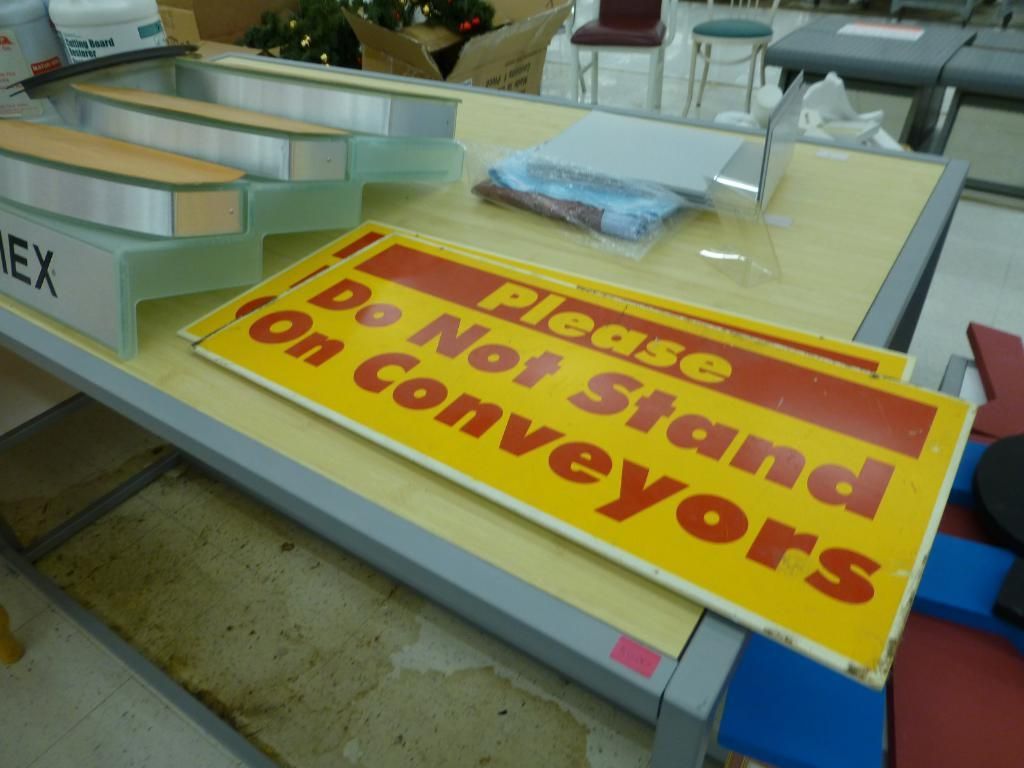What type of furniture is present in the image? There is a table and chairs in the image. What is on the table in the image? The table has name boards on it. Where are the chairs located in the image? The chairs are on the floor. What is on the tables on the floor? Cardboard boxes are present on the tables. Who is the creator of the butter in the image? There is no butter present in the image, so it is not possible to determine the creator. 